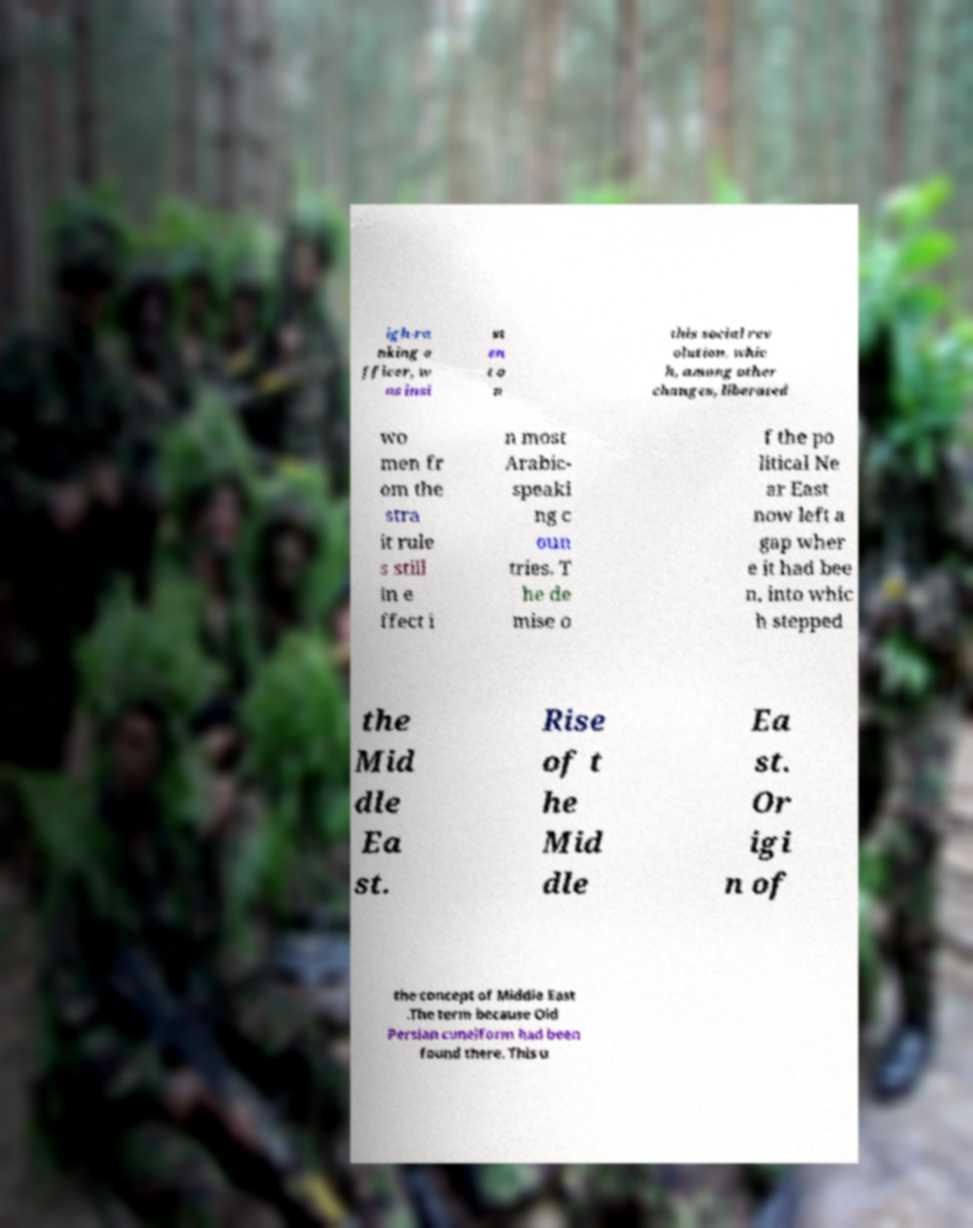Could you extract and type out the text from this image? igh-ra nking o fficer, w as insi st en t o n this social rev olution, whic h, among other changes, liberated wo men fr om the stra it rule s still in e ffect i n most Arabic- speaki ng c oun tries. T he de mise o f the po litical Ne ar East now left a gap wher e it had bee n, into whic h stepped the Mid dle Ea st. Rise of t he Mid dle Ea st. Or igi n of the concept of Middle East .The term because Old Persian cuneiform had been found there. This u 